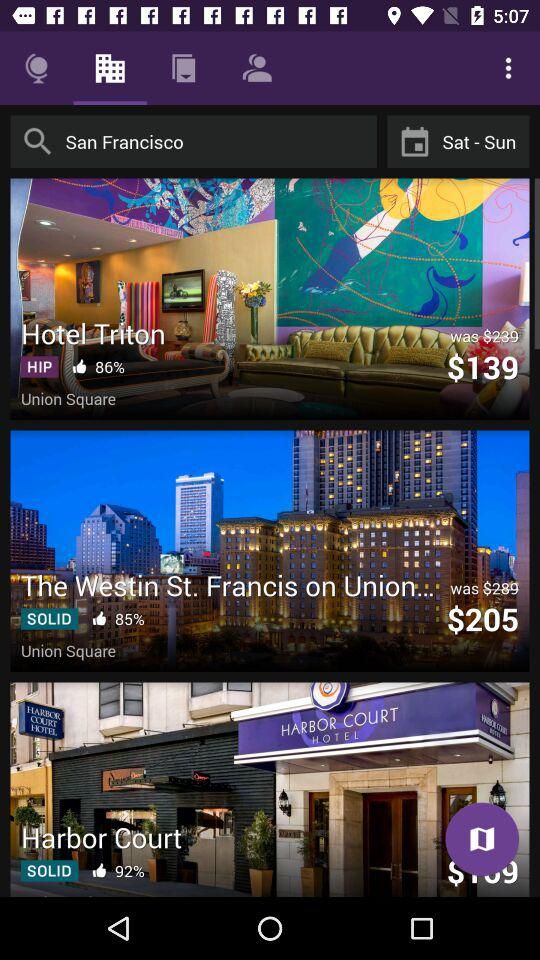What is the cost of Hotel Triton? The cost of the Hotel Triton is $139. 